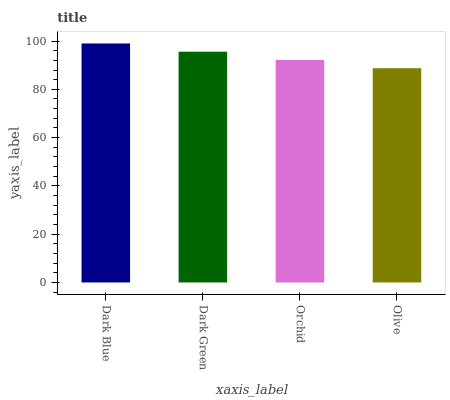Is Olive the minimum?
Answer yes or no. Yes. Is Dark Blue the maximum?
Answer yes or no. Yes. Is Dark Green the minimum?
Answer yes or no. No. Is Dark Green the maximum?
Answer yes or no. No. Is Dark Blue greater than Dark Green?
Answer yes or no. Yes. Is Dark Green less than Dark Blue?
Answer yes or no. Yes. Is Dark Green greater than Dark Blue?
Answer yes or no. No. Is Dark Blue less than Dark Green?
Answer yes or no. No. Is Dark Green the high median?
Answer yes or no. Yes. Is Orchid the low median?
Answer yes or no. Yes. Is Orchid the high median?
Answer yes or no. No. Is Dark Blue the low median?
Answer yes or no. No. 